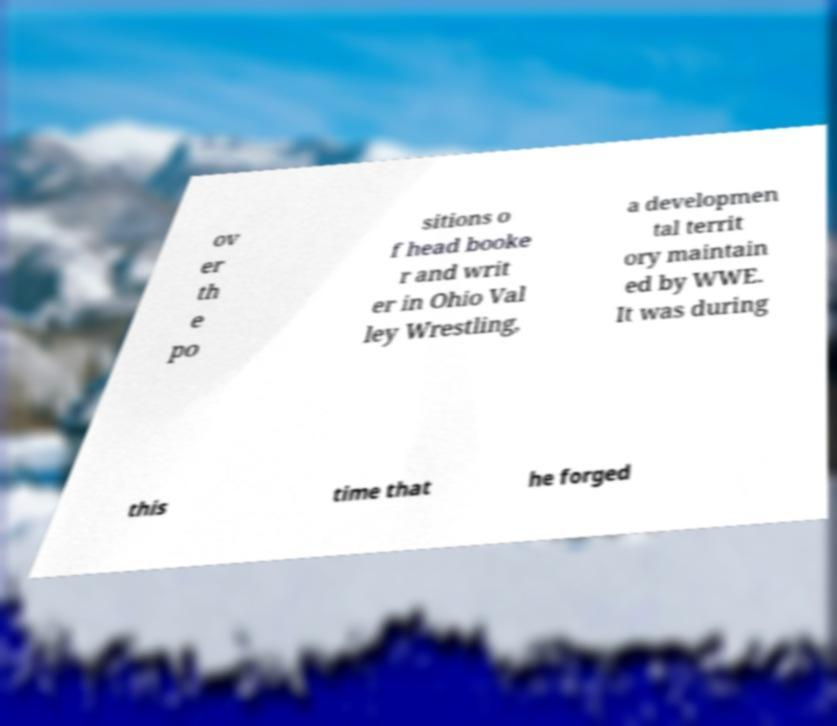I need the written content from this picture converted into text. Can you do that? ov er th e po sitions o f head booke r and writ er in Ohio Val ley Wrestling, a developmen tal territ ory maintain ed by WWE. It was during this time that he forged 